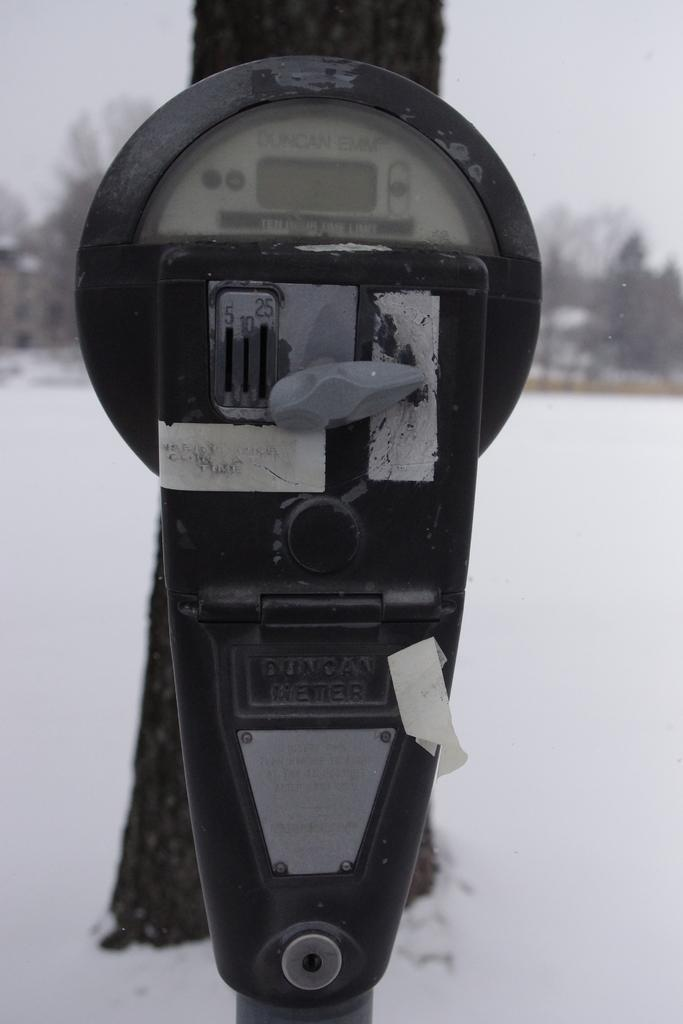<image>
Relay a brief, clear account of the picture shown. PARKING METER IN FRONT OF A TREE WITH SNOW ON THE GROUND 